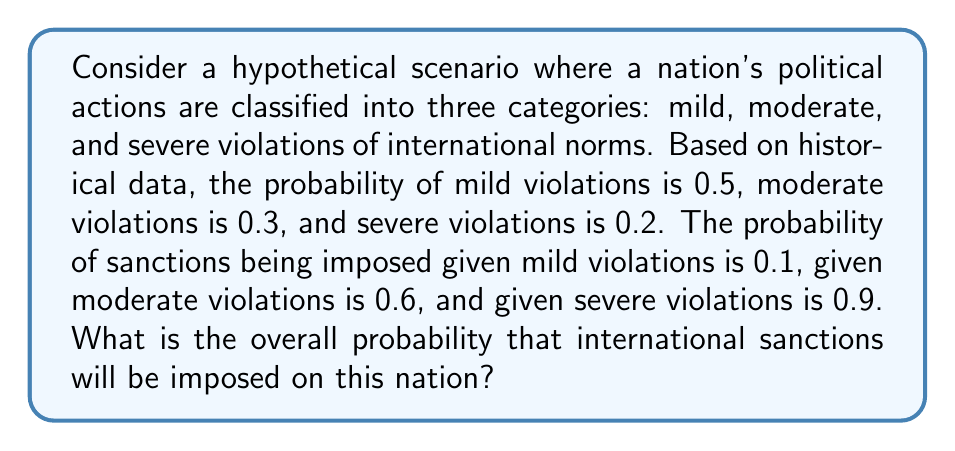Could you help me with this problem? To solve this problem, we'll use the law of total probability. Let's break it down step-by-step:

1. Define events:
   S: Sanctions are imposed
   M: Mild violations
   D: Moderate violations
   V: Severe violations

2. Given probabilities:
   $P(M) = 0.5$, $P(D) = 0.3$, $P(V) = 0.2$
   $P(S|M) = 0.1$, $P(S|D) = 0.6$, $P(S|V) = 0.9$

3. Law of Total Probability formula:
   $P(S) = P(S|M)P(M) + P(S|D)P(D) + P(S|V)P(V)$

4. Substitute the values:
   $P(S) = (0.1)(0.5) + (0.6)(0.3) + (0.9)(0.2)$

5. Calculate:
   $P(S) = 0.05 + 0.18 + 0.18 = 0.41$

Therefore, the overall probability of sanctions being imposed is 0.41 or 41%.
Answer: 0.41 